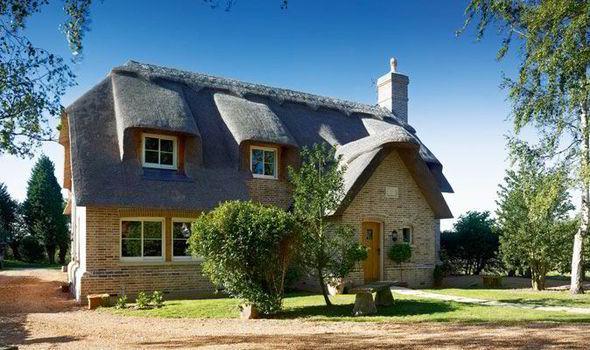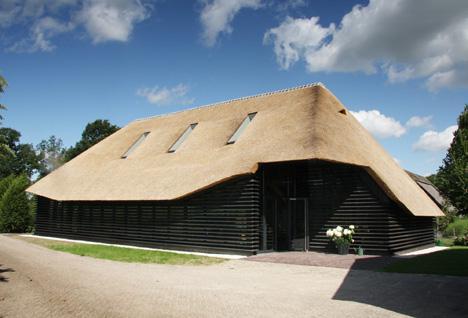The first image is the image on the left, the second image is the image on the right. For the images shown, is this caption "One roof is partly supported by posts." true? Answer yes or no. No. The first image is the image on the left, the second image is the image on the right. Assess this claim about the two images: "The house on the left is behind a fence.". Correct or not? Answer yes or no. No. 